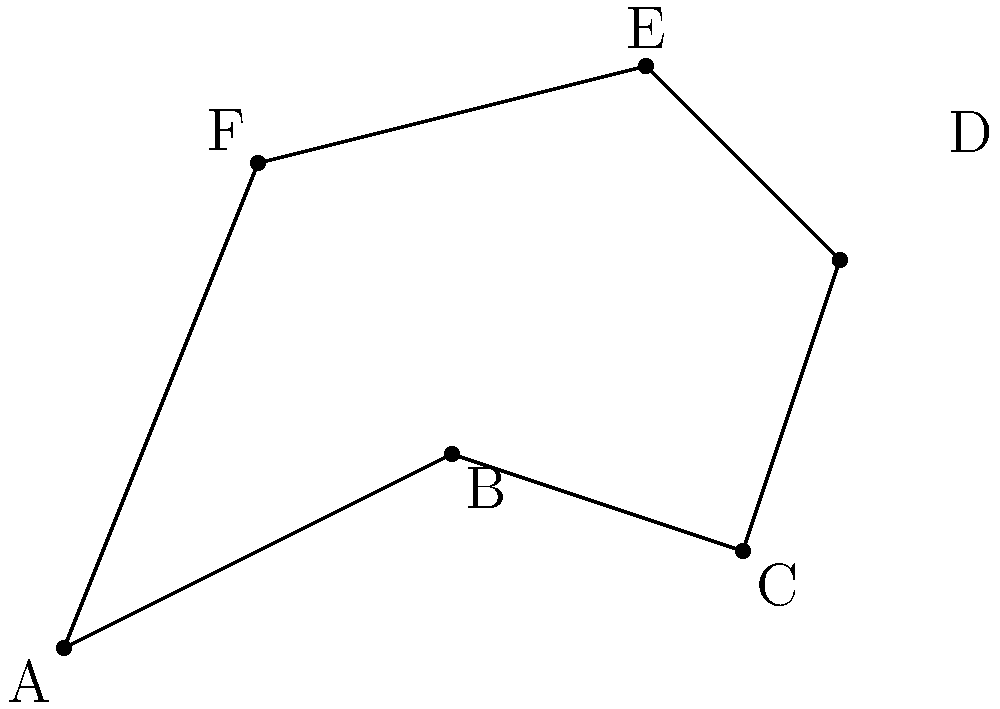During a phagocytosis event, a macrophage's membrane forms an irregular shape around a pathogen. The shape can be approximated by the hexagon ABCDEF shown in the figure. Given that AB = 4.47 μm, BC = 3.16 μm, CD = 3.61 μm, DE = 2.83 μm, EF = 4.47 μm, and FA = 5.39 μm, calculate the perimeter of the macrophage's membrane in micrometers (μm). To calculate the perimeter of the irregular hexagon representing the macrophage's membrane during phagocytosis, we need to sum up the lengths of all sides:

1. Side AB = 4.47 μm
2. Side BC = 3.16 μm
3. Side CD = 3.61 μm
4. Side DE = 2.83 μm
5. Side EF = 4.47 μm
6. Side FA = 5.39 μm

The perimeter is the sum of all these lengths:

$$ \text{Perimeter} = AB + BC + CD + DE + EF + FA $$

$$ \text{Perimeter} = 4.47 + 3.16 + 3.61 + 2.83 + 4.47 + 5.39 $$

$$ \text{Perimeter} = 23.93 \text{ μm} $$

Therefore, the perimeter of the macrophage's membrane during this phagocytosis event is approximately 23.93 μm.
Answer: 23.93 μm 